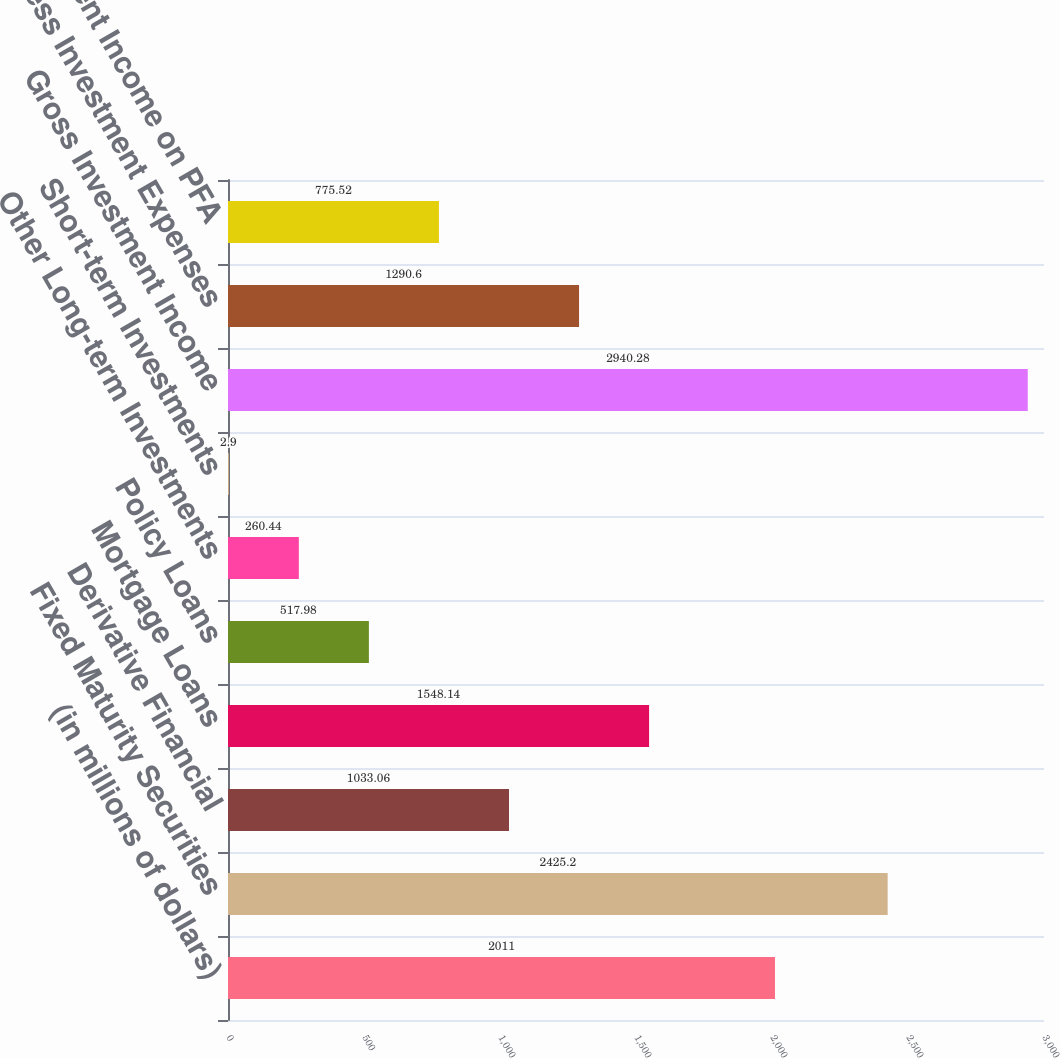Convert chart to OTSL. <chart><loc_0><loc_0><loc_500><loc_500><bar_chart><fcel>(in millions of dollars)<fcel>Fixed Maturity Securities<fcel>Derivative Financial<fcel>Mortgage Loans<fcel>Policy Loans<fcel>Other Long-term Investments<fcel>Short-term Investments<fcel>Gross Investment Income<fcel>Less Investment Expenses<fcel>Less Investment Income on PFA<nl><fcel>2011<fcel>2425.2<fcel>1033.06<fcel>1548.14<fcel>517.98<fcel>260.44<fcel>2.9<fcel>2940.28<fcel>1290.6<fcel>775.52<nl></chart> 